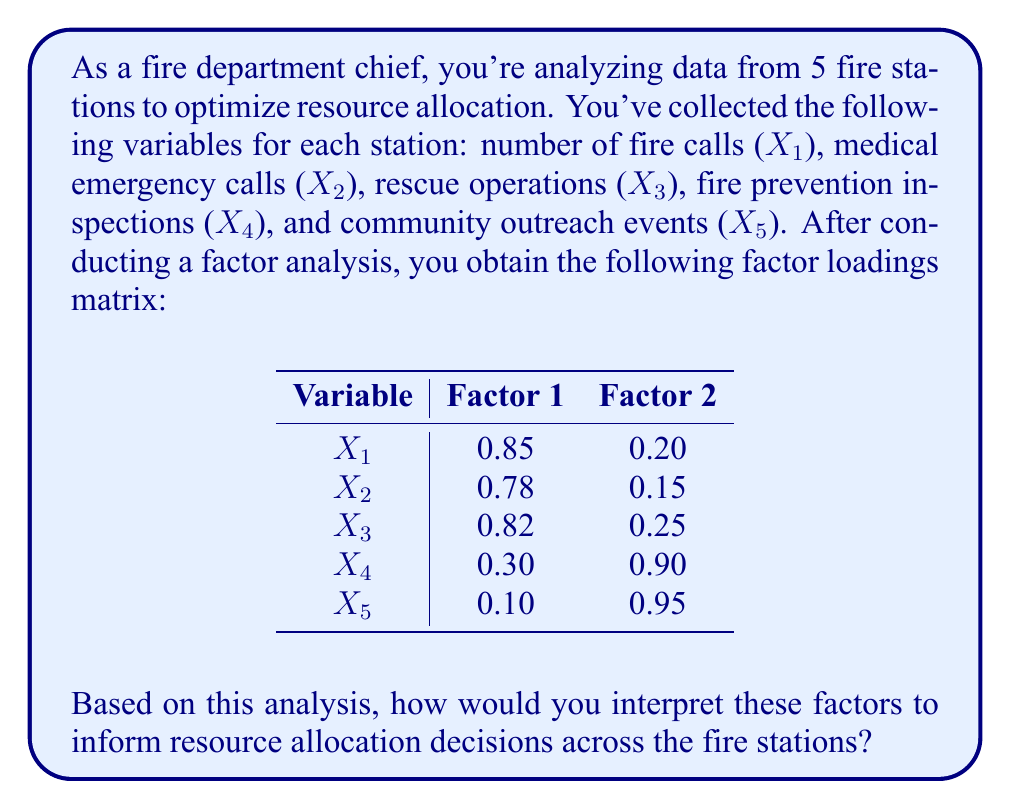Can you answer this question? To interpret the factors and make informed resource allocation decisions, we'll follow these steps:

1. Examine the factor loadings:
   Factor loadings represent the correlation between each variable and the factor. Generally, loadings above 0.7 are considered high.

2. Interpret Factor 1:
   - X1 (fire calls): 0.85
   - X2 (medical emergency calls): 0.78
   - X3 (rescue operations): 0.82
   These variables have high loadings on Factor 1, suggesting it represents emergency response activities.

3. Interpret Factor 2:
   - X4 (fire prevention inspections): 0.90
   - X5 (community outreach events): 0.95
   These variables have high loadings on Factor 2, indicating it represents preventive and community-oriented activities.

4. Name the factors:
   - Factor 1: "Emergency Response"
   - Factor 2: "Prevention and Community Engagement"

5. Resource allocation implications:
   - Stations with high scores on Factor 1 may need more resources for emergency response equipment and personnel.
   - Stations with high scores on Factor 2 may require resources for prevention programs and community outreach.

6. Balanced approach:
   As a fiscally responsible chief, you should allocate resources to maintain a balance between both factors across all stations, ensuring effective emergency response while also investing in prevention and community engagement.

7. Data-driven decision making:
   Use the factor scores for each station to determine their strengths and weaknesses in each area, allowing for targeted resource allocation to address specific needs.

8. Continuous monitoring:
   Regularly update the factor analysis to track changes in station performance and adjust resource allocation accordingly.
Answer: Interpret Factor 1 as "Emergency Response" and Factor 2 as "Prevention and Community Engagement". Allocate resources based on station-specific factor scores to balance emergency readiness with preventive measures, ensuring fiscal responsibility. 